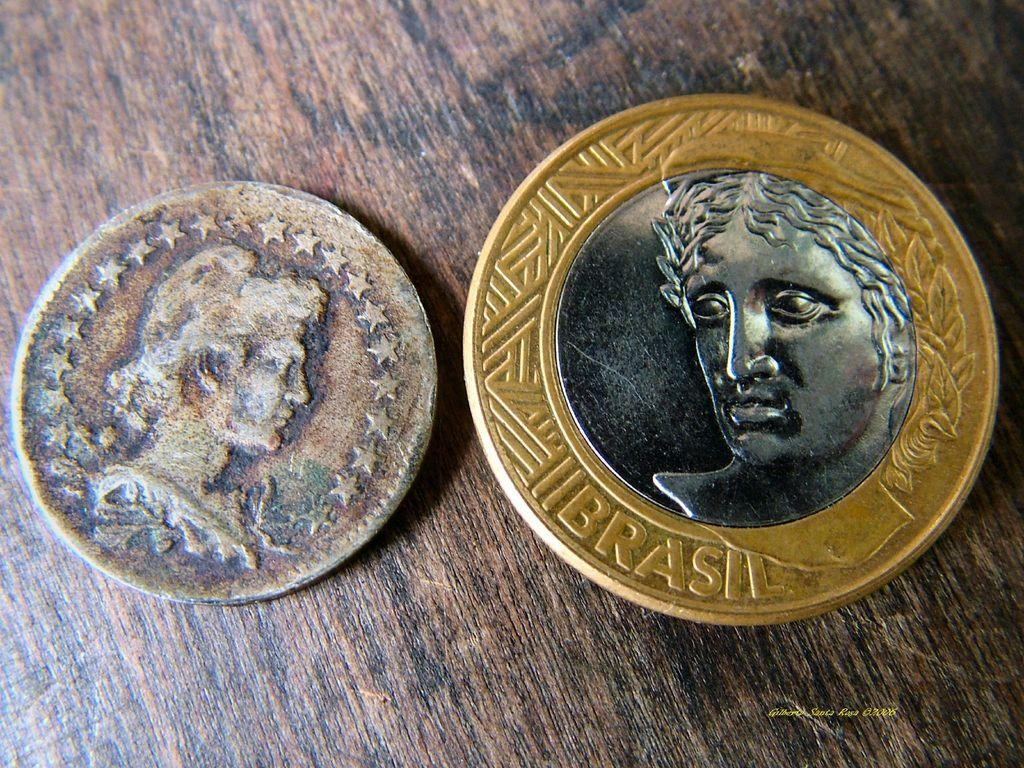<image>
Offer a succinct explanation of the picture presented. A gold bordered coin with the word brasil is next to a rusted coin on a brown table. 